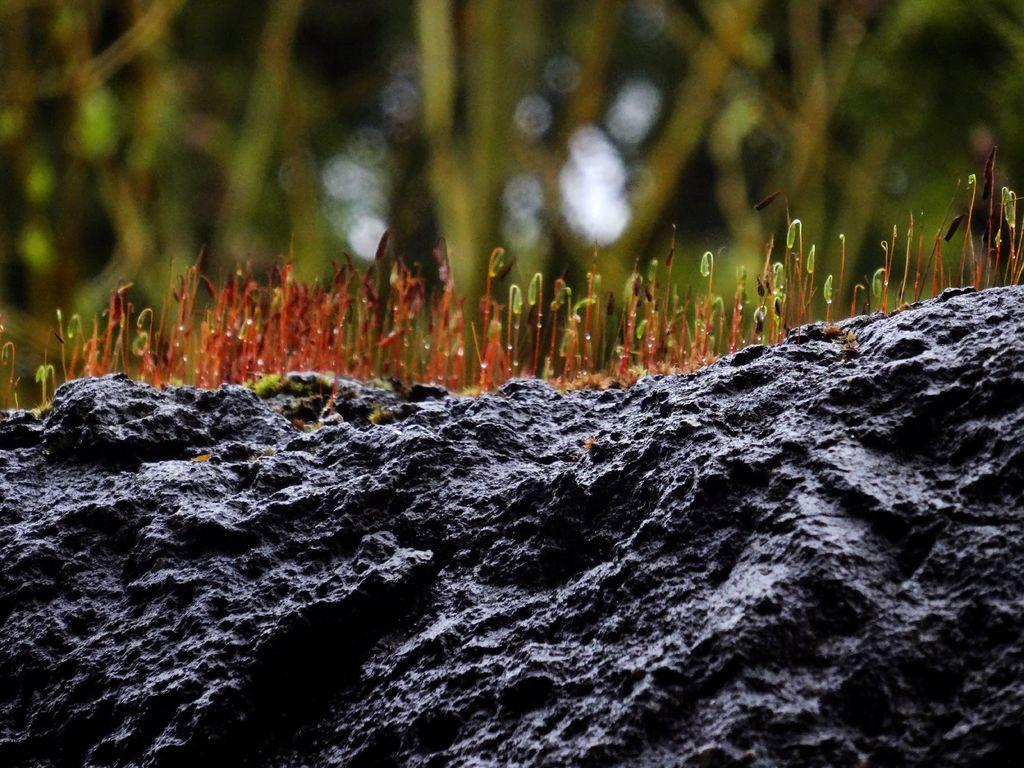What type of living organisms can be seen in the image? Plants can be seen in the image. What non-living object is present in the image? There is a rock in the image. What type of powder can be seen on the island in the image? There is no island or powder present in the image; it only features plants and a rock. 